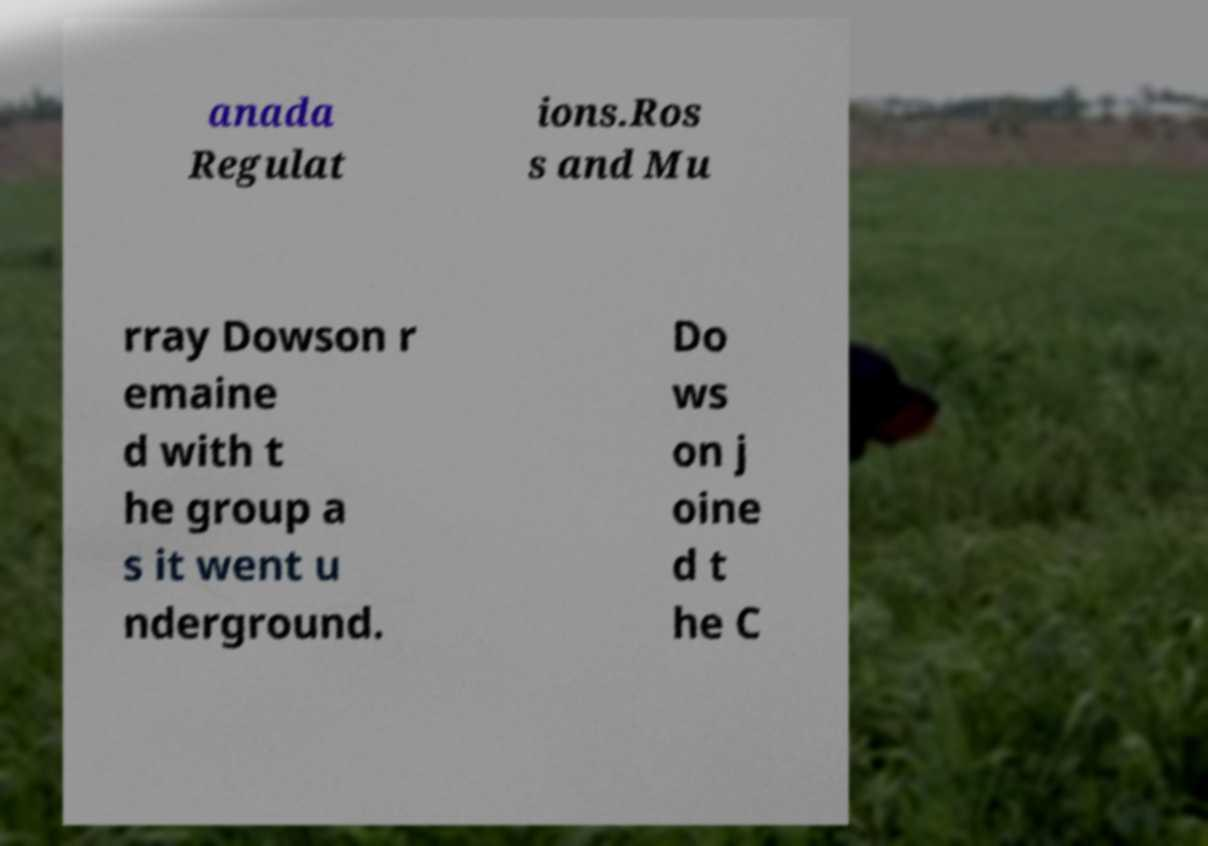Please read and relay the text visible in this image. What does it say? anada Regulat ions.Ros s and Mu rray Dowson r emaine d with t he group a s it went u nderground. Do ws on j oine d t he C 